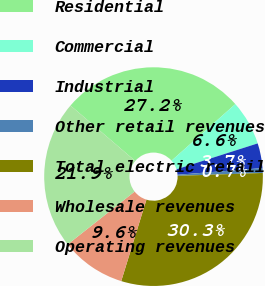Convert chart. <chart><loc_0><loc_0><loc_500><loc_500><pie_chart><fcel>Residential<fcel>Commercial<fcel>Industrial<fcel>Other retail revenues<fcel>Total electric retail<fcel>Wholesale revenues<fcel>Operating revenues<nl><fcel>27.18%<fcel>6.63%<fcel>3.67%<fcel>0.71%<fcel>30.31%<fcel>9.59%<fcel>21.91%<nl></chart> 